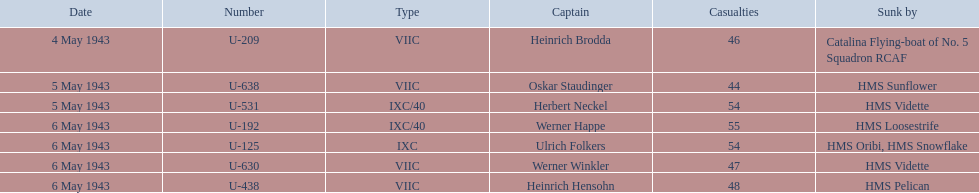Who are all of the captains? Heinrich Brodda, Oskar Staudinger, Herbert Neckel, Werner Happe, Ulrich Folkers, Werner Winkler, Heinrich Hensohn. What sunk each of the captains? Catalina Flying-boat of No. 5 Squadron RCAF, HMS Sunflower, HMS Vidette, HMS Loosestrife, HMS Oribi, HMS Snowflake, HMS Vidette, HMS Pelican. Which was sunk by the hms pelican? Heinrich Hensohn. 